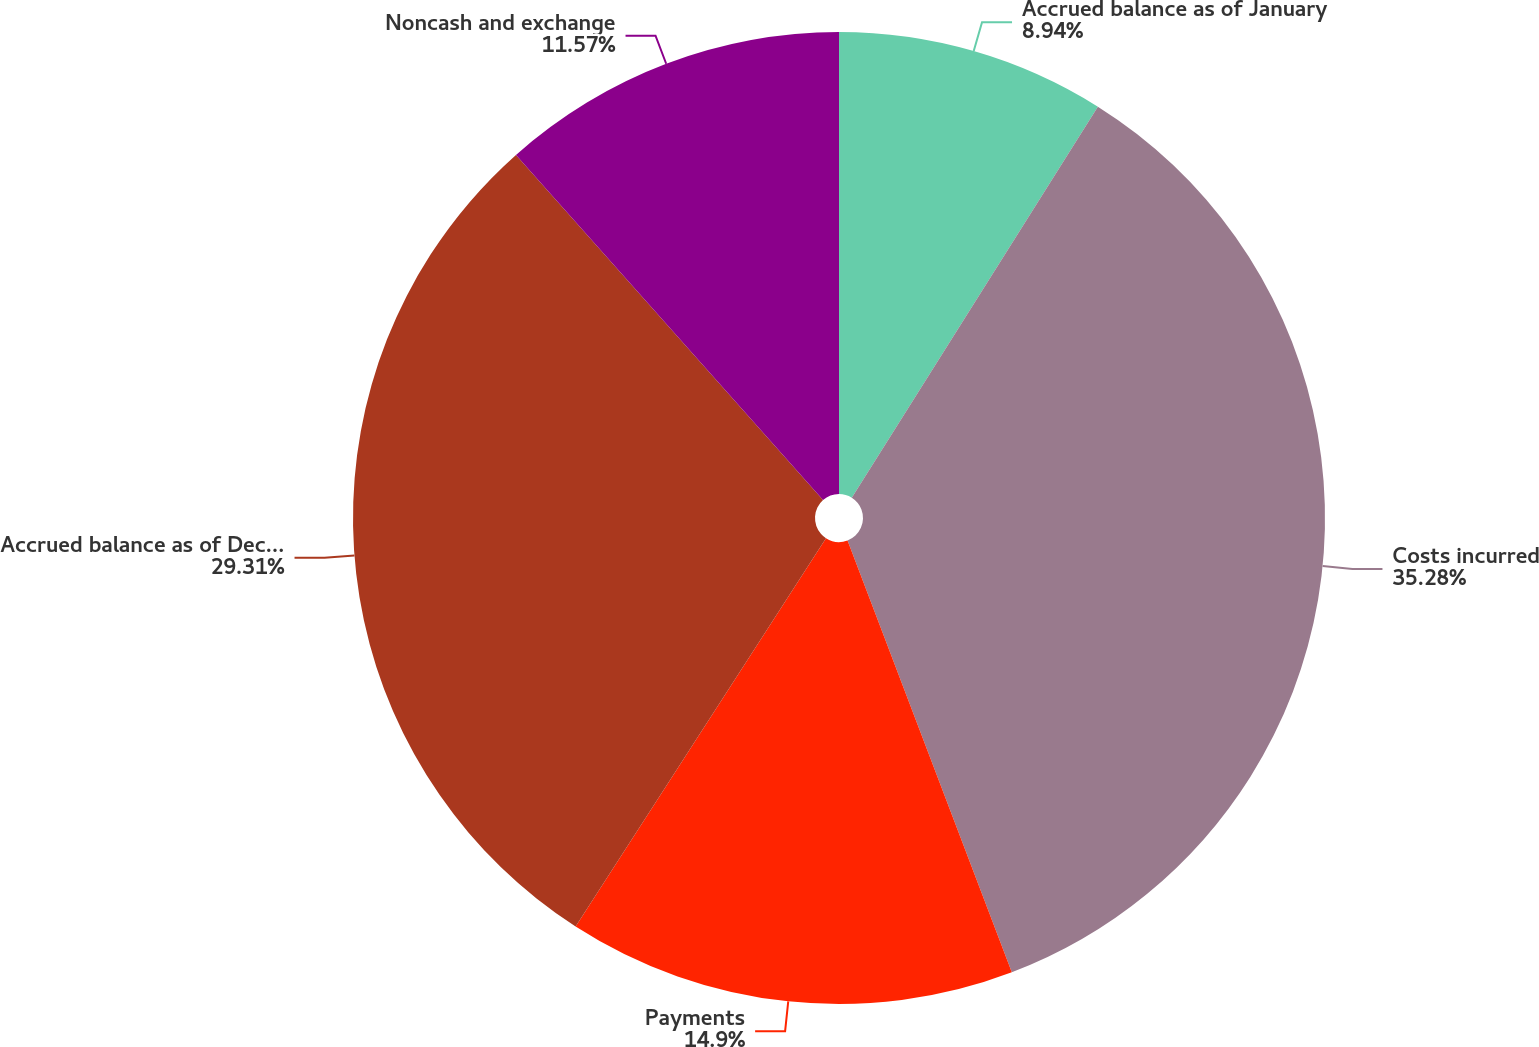Convert chart to OTSL. <chart><loc_0><loc_0><loc_500><loc_500><pie_chart><fcel>Accrued balance as of January<fcel>Costs incurred<fcel>Payments<fcel>Accrued balance as of December<fcel>Noncash and exchange<nl><fcel>8.94%<fcel>35.27%<fcel>14.9%<fcel>29.31%<fcel>11.57%<nl></chart> 